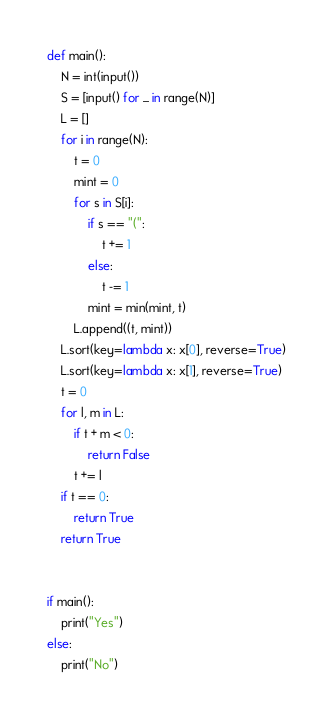<code> <loc_0><loc_0><loc_500><loc_500><_Python_>def main():
    N = int(input())
    S = [input() for _ in range(N)]
    L = []
    for i in range(N):
        t = 0
        mint = 0
        for s in S[i]:
            if s == "(":
                t += 1
            else:
                t -= 1
            mint = min(mint, t)
        L.append((t, mint))
    L.sort(key=lambda x: x[0], reverse=True)
    L.sort(key=lambda x: x[1], reverse=True)
    t = 0
    for l, m in L:
        if t + m < 0:
            return False
        t += l
    if t == 0:
        return True
    return True


if main():
    print("Yes")
else:
    print("No")
</code> 